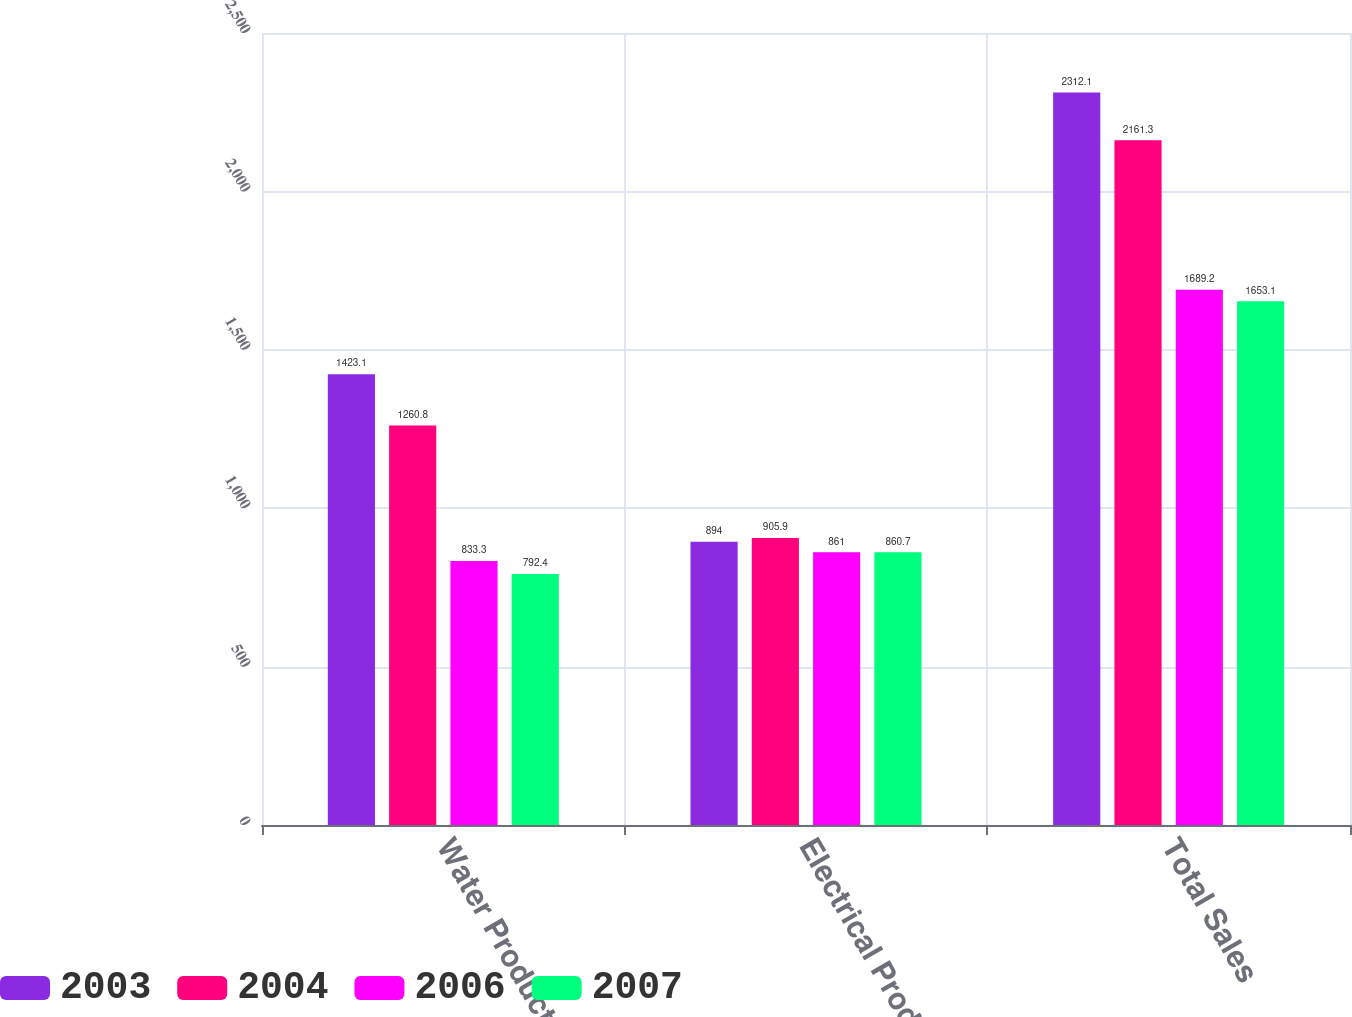Convert chart. <chart><loc_0><loc_0><loc_500><loc_500><stacked_bar_chart><ecel><fcel>Water Products<fcel>Electrical Products<fcel>Total Sales<nl><fcel>2003<fcel>1423.1<fcel>894<fcel>2312.1<nl><fcel>2004<fcel>1260.8<fcel>905.9<fcel>2161.3<nl><fcel>2006<fcel>833.3<fcel>861<fcel>1689.2<nl><fcel>2007<fcel>792.4<fcel>860.7<fcel>1653.1<nl></chart> 